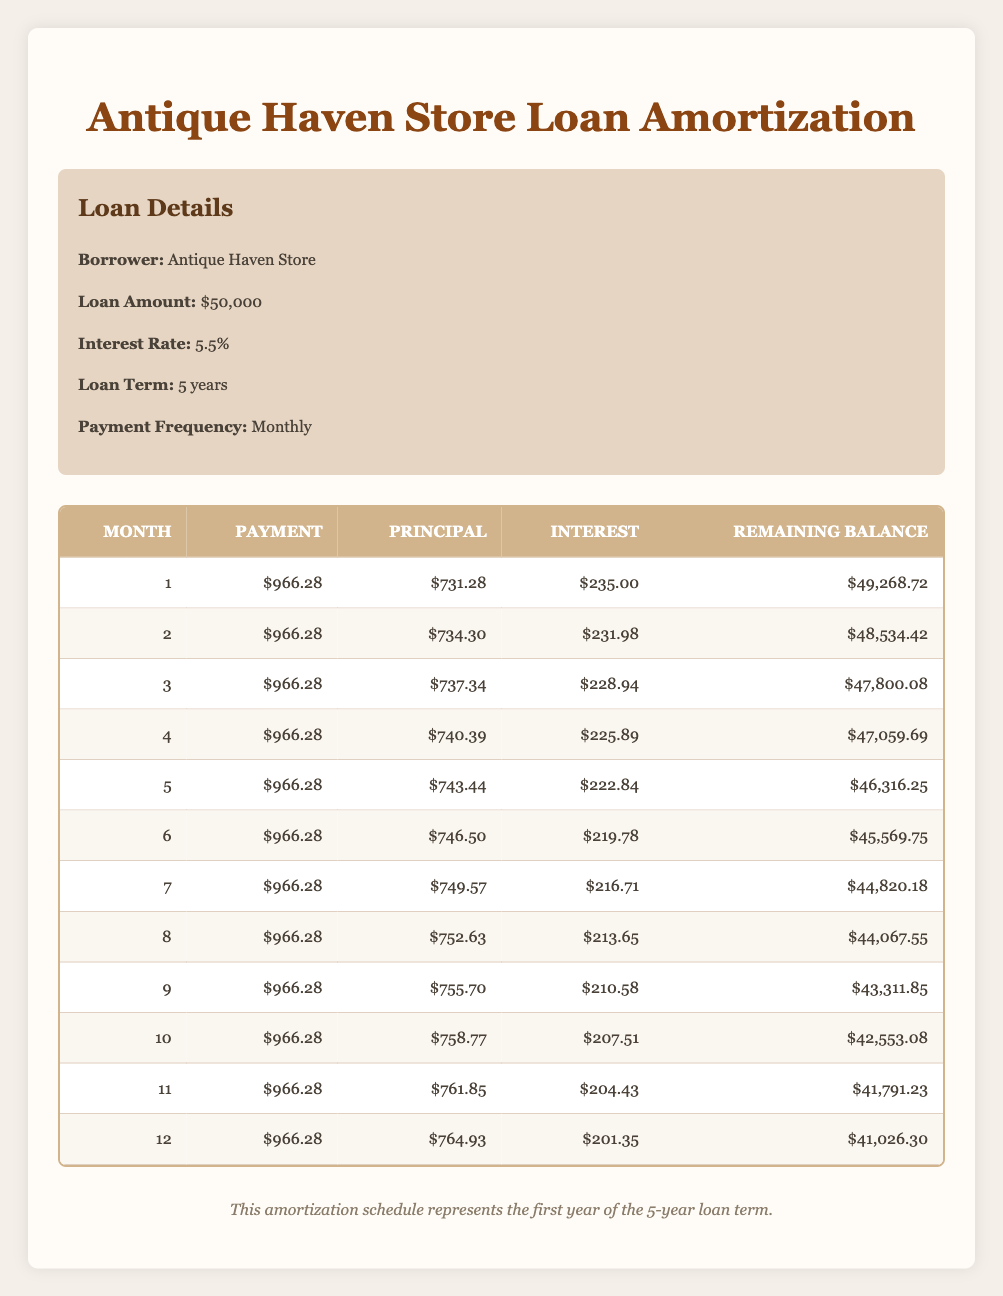What is the total payment amount for the first month? The table shows that the payment for the first month is listed as 966.28.
Answer: 966.28 In which month does the principal payment first exceed the amount of interest paid? Looking at the amortization schedule, in month 1, the principal payment is 731.28 and the interest is 235.00. In month 2, the principal is 734.30 and interest is 231.98. Continuing this pattern, month 3 shows principal 737.34 and interest 228.94, detailing that each month the principal payment increases. We can see that in every month, the principal payment exceeds the interest.
Answer: Month 1 What is the difference between the principal payment in month 5 and month 1? The principal paid in month 5 is 743.44, while in month 1 it is 731.28. The difference is calculated by subtracting month 1 from month 5: 743.44 - 731.28 = 12.16.
Answer: 12.16 Is the total interest paid in the first year more than $2,600? To determine this, we need to sum the interest amounts from months 1 to 12. Adding up the interest from each month gives us: 235.00 + 231.98 + 228.94 + 225.89 + 222.84 + 219.78 + 216.71 + 213.65 + 210.58 + 207.51 + 204.43 + 201.35 = 2,575.67. Since this total is less than 2,600, the answer is no.
Answer: No What is the average principal payment for the first 12 months? To find the average principal payment, we first sum the principal payments for the first 12 months: 731.28 + 734.30 + 737.34 + 740.39 + 743.44 + 746.50 + 749.57 + 752.63 + 755.70 + 758.77 + 761.85 + 764.93 = 8,702.70. Dividing this total by 12 gives us the average principal payment: 8,702.70 / 12 ≈ 725.23.
Answer: 725.23 In month 6, what is the remaining balance? According to the table, the remaining balance after month 6 is 45,569.75.
Answer: 45,569.75 